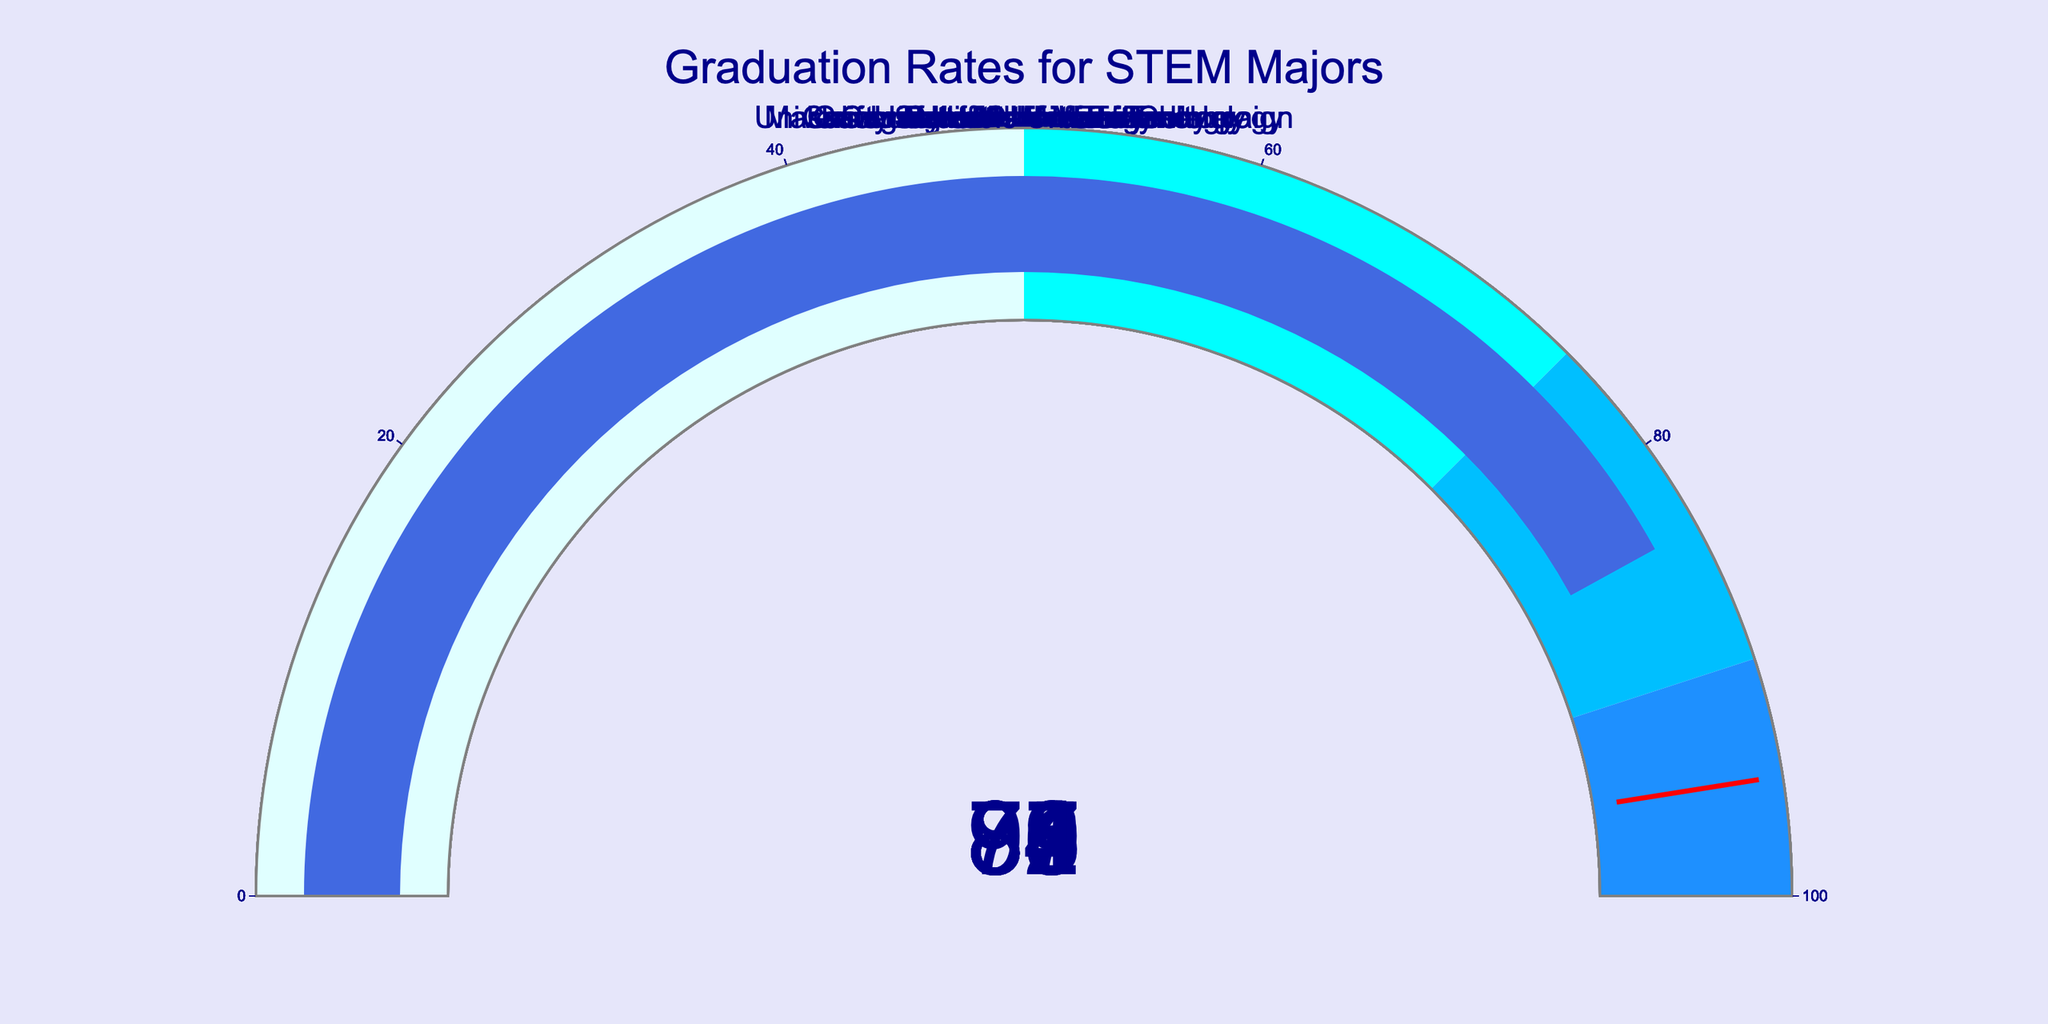what is the graduation rate of Stanford University? The gauge chart displays a number corresponding to the graduation rate for each university. The number for Stanford University is 89.
Answer: 89 How many universities have a graduation rate of 85 or higher? By looking at the numbers on each gauge, count the universities with rates of 85 or higher: MIT (92), Stanford (89), Caltech (86), Georgia Tech (85), Carnegie Mellon (88), Cornell (87), and UIUC (84). Hence, 7 universities have rates of 85 or higher.
Answer: 7 Which university has the lowest graduation rate? By examining all gauges, identify the university with the smallest number. Purdue University has the lowest graduation rate at 79.
Answer: Purdue University What is the average graduation rate of all the universities listed? Sum the graduation rates: (92 + 89 + 86 + 85 + 88 + 81 + 83 + 79 + 87 + 84) = 854. Divide by the number of universities, which is 10. The average is 854/10 = 85.4.
Answer: 85.4 Which university has a higher graduation rate, UC Berkeley or UIUC? Check the numbers on the gauges for UC Berkeley and UIUC; UC Berkeley is 81 and UIUC is 84. So, UIUC has a higher graduation rate.
Answer: UIUC How many universities have a graduation rate higher than 87? Examine the gauges to see which rates are higher than 87: MIT (92), Stanford (89), Carnegie Mellon (88) making it 3 universities.
Answer: 3 What's the difference in graduation rates between MIT and Purdue University? MIT’s rate is 92 and Purdue University’s rate is 79. Calculate the difference: 92 - 79 = 13.
Answer: 13 Which range (0-50, 50-75, 75-90, 90-100) has the most universities? Look at the colors indicating ranges: 0-50 has none, 50-75 has none, 75-90 has 7, and 90-100 has 1. The range 75-90 has the most universities.
Answer: 75-90 